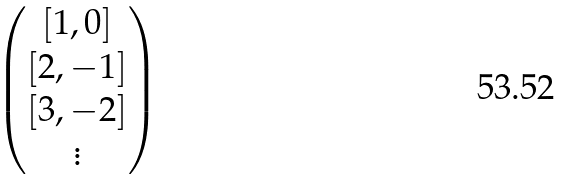Convert formula to latex. <formula><loc_0><loc_0><loc_500><loc_500>\begin{pmatrix} [ 1 , 0 ] \\ [ 2 , - 1 ] \\ [ 3 , - 2 ] \\ \vdots \end{pmatrix}</formula> 